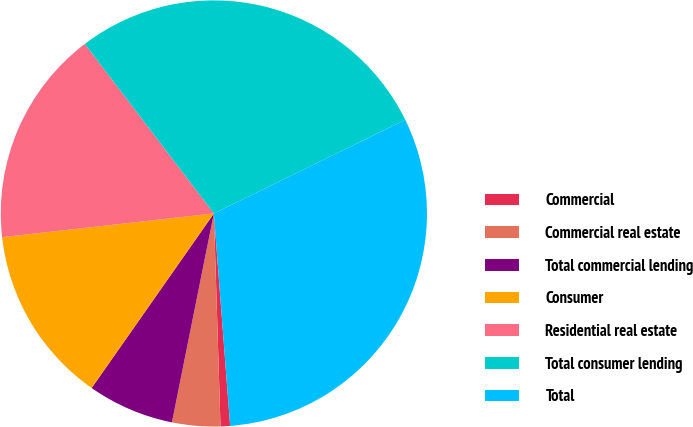<chart> <loc_0><loc_0><loc_500><loc_500><pie_chart><fcel>Commercial<fcel>Commercial real estate<fcel>Total commercial lending<fcel>Consumer<fcel>Residential real estate<fcel>Total consumer lending<fcel>Total<nl><fcel>0.72%<fcel>3.65%<fcel>6.57%<fcel>13.5%<fcel>16.42%<fcel>28.11%<fcel>31.03%<nl></chart> 